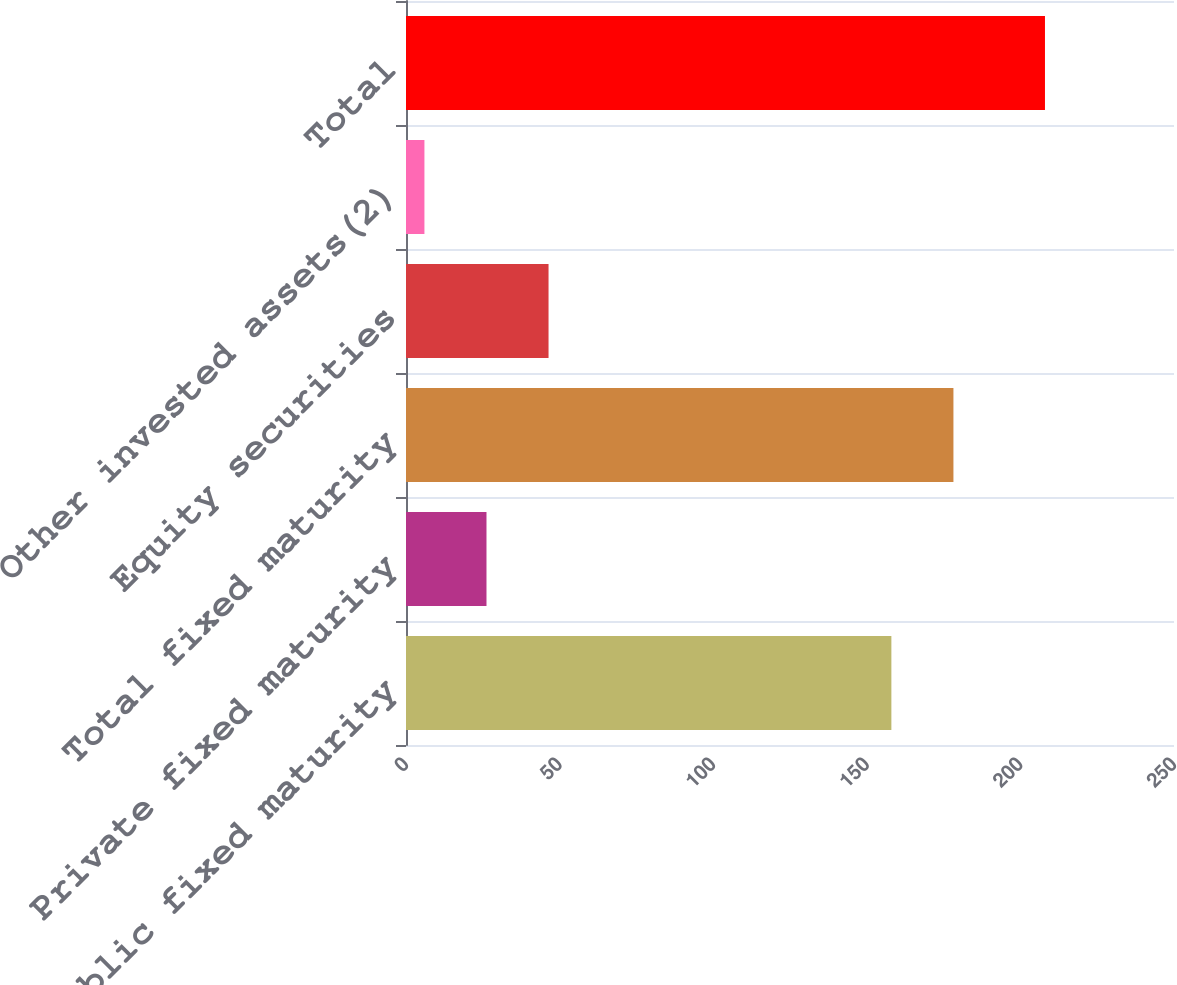Convert chart to OTSL. <chart><loc_0><loc_0><loc_500><loc_500><bar_chart><fcel>Public fixed maturity<fcel>Private fixed maturity<fcel>Total fixed maturity<fcel>Equity securities<fcel>Other invested assets(2)<fcel>Total<nl><fcel>158<fcel>26.2<fcel>178.2<fcel>46.4<fcel>6<fcel>208<nl></chart> 